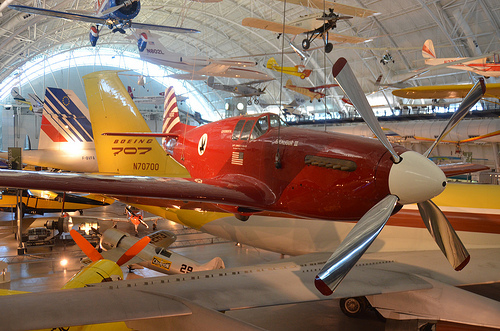<image>
Is there a propeller in the plane? No. The propeller is not contained within the plane. These objects have a different spatial relationship. 